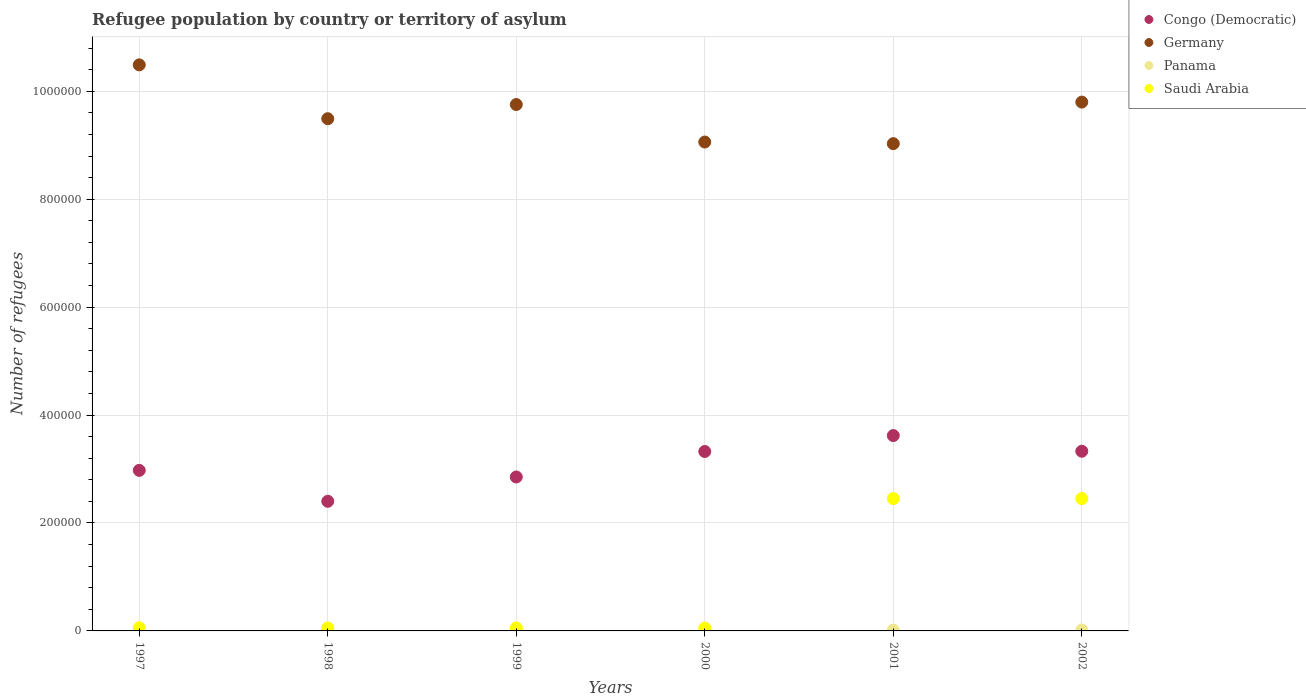What is the number of refugees in Saudi Arabia in 2002?
Make the answer very short. 2.45e+05. Across all years, what is the maximum number of refugees in Panama?
Give a very brief answer. 1573. Across all years, what is the minimum number of refugees in Saudi Arabia?
Offer a terse response. 5309. What is the total number of refugees in Saudi Arabia in the graph?
Your response must be concise. 5.13e+05. What is the difference between the number of refugees in Congo (Democratic) in 1997 and that in 1999?
Provide a short and direct response. 1.23e+04. What is the difference between the number of refugees in Congo (Democratic) in 2002 and the number of refugees in Germany in 1997?
Give a very brief answer. -7.16e+05. What is the average number of refugees in Congo (Democratic) per year?
Your answer should be compact. 3.08e+05. In the year 2000, what is the difference between the number of refugees in Saudi Arabia and number of refugees in Congo (Democratic)?
Ensure brevity in your answer.  -3.27e+05. What is the ratio of the number of refugees in Germany in 1999 to that in 2002?
Give a very brief answer. 1. What is the difference between the highest and the second highest number of refugees in Congo (Democratic)?
Make the answer very short. 2.90e+04. What is the difference between the highest and the lowest number of refugees in Germany?
Give a very brief answer. 1.46e+05. In how many years, is the number of refugees in Germany greater than the average number of refugees in Germany taken over all years?
Make the answer very short. 3. Is the sum of the number of refugees in Panama in 2000 and 2002 greater than the maximum number of refugees in Germany across all years?
Ensure brevity in your answer.  No. Does the number of refugees in Panama monotonically increase over the years?
Provide a succinct answer. No. Is the number of refugees in Saudi Arabia strictly less than the number of refugees in Panama over the years?
Give a very brief answer. No. How many dotlines are there?
Provide a short and direct response. 4. What is the difference between two consecutive major ticks on the Y-axis?
Make the answer very short. 2.00e+05. Are the values on the major ticks of Y-axis written in scientific E-notation?
Offer a terse response. No. Does the graph contain grids?
Ensure brevity in your answer.  Yes. How many legend labels are there?
Your answer should be very brief. 4. How are the legend labels stacked?
Your response must be concise. Vertical. What is the title of the graph?
Provide a succinct answer. Refugee population by country or territory of asylum. What is the label or title of the Y-axis?
Keep it short and to the point. Number of refugees. What is the Number of refugees in Congo (Democratic) in 1997?
Offer a very short reply. 2.98e+05. What is the Number of refugees in Germany in 1997?
Make the answer very short. 1.05e+06. What is the Number of refugees of Panama in 1997?
Your answer should be compact. 622. What is the Number of refugees in Saudi Arabia in 1997?
Make the answer very short. 5833. What is the Number of refugees in Congo (Democratic) in 1998?
Make the answer very short. 2.40e+05. What is the Number of refugees in Germany in 1998?
Provide a short and direct response. 9.49e+05. What is the Number of refugees of Panama in 1998?
Make the answer very short. 1188. What is the Number of refugees in Saudi Arabia in 1998?
Offer a terse response. 5531. What is the Number of refugees of Congo (Democratic) in 1999?
Give a very brief answer. 2.85e+05. What is the Number of refugees of Germany in 1999?
Offer a very short reply. 9.76e+05. What is the Number of refugees of Panama in 1999?
Give a very brief answer. 1321. What is the Number of refugees of Saudi Arabia in 1999?
Provide a short and direct response. 5562. What is the Number of refugees of Congo (Democratic) in 2000?
Keep it short and to the point. 3.33e+05. What is the Number of refugees of Germany in 2000?
Offer a terse response. 9.06e+05. What is the Number of refugees in Panama in 2000?
Give a very brief answer. 1313. What is the Number of refugees in Saudi Arabia in 2000?
Offer a very short reply. 5309. What is the Number of refugees in Congo (Democratic) in 2001?
Provide a succinct answer. 3.62e+05. What is the Number of refugees of Germany in 2001?
Your answer should be compact. 9.03e+05. What is the Number of refugees of Panama in 2001?
Your response must be concise. 1470. What is the Number of refugees of Saudi Arabia in 2001?
Ensure brevity in your answer.  2.45e+05. What is the Number of refugees of Congo (Democratic) in 2002?
Offer a very short reply. 3.33e+05. What is the Number of refugees in Germany in 2002?
Your answer should be compact. 9.80e+05. What is the Number of refugees in Panama in 2002?
Give a very brief answer. 1573. What is the Number of refugees of Saudi Arabia in 2002?
Offer a terse response. 2.45e+05. Across all years, what is the maximum Number of refugees of Congo (Democratic)?
Give a very brief answer. 3.62e+05. Across all years, what is the maximum Number of refugees of Germany?
Keep it short and to the point. 1.05e+06. Across all years, what is the maximum Number of refugees in Panama?
Offer a terse response. 1573. Across all years, what is the maximum Number of refugees of Saudi Arabia?
Offer a terse response. 2.45e+05. Across all years, what is the minimum Number of refugees in Congo (Democratic)?
Your response must be concise. 2.40e+05. Across all years, what is the minimum Number of refugees in Germany?
Provide a succinct answer. 9.03e+05. Across all years, what is the minimum Number of refugees in Panama?
Give a very brief answer. 622. Across all years, what is the minimum Number of refugees in Saudi Arabia?
Your answer should be compact. 5309. What is the total Number of refugees of Congo (Democratic) in the graph?
Offer a very short reply. 1.85e+06. What is the total Number of refugees of Germany in the graph?
Your answer should be very brief. 5.76e+06. What is the total Number of refugees of Panama in the graph?
Give a very brief answer. 7487. What is the total Number of refugees in Saudi Arabia in the graph?
Offer a terse response. 5.13e+05. What is the difference between the Number of refugees of Congo (Democratic) in 1997 and that in 1998?
Keep it short and to the point. 5.73e+04. What is the difference between the Number of refugees of Germany in 1997 and that in 1998?
Make the answer very short. 9.98e+04. What is the difference between the Number of refugees of Panama in 1997 and that in 1998?
Provide a succinct answer. -566. What is the difference between the Number of refugees of Saudi Arabia in 1997 and that in 1998?
Give a very brief answer. 302. What is the difference between the Number of refugees of Congo (Democratic) in 1997 and that in 1999?
Provide a succinct answer. 1.23e+04. What is the difference between the Number of refugees of Germany in 1997 and that in 1999?
Ensure brevity in your answer.  7.35e+04. What is the difference between the Number of refugees of Panama in 1997 and that in 1999?
Make the answer very short. -699. What is the difference between the Number of refugees of Saudi Arabia in 1997 and that in 1999?
Your answer should be very brief. 271. What is the difference between the Number of refugees in Congo (Democratic) in 1997 and that in 2000?
Keep it short and to the point. -3.50e+04. What is the difference between the Number of refugees of Germany in 1997 and that in 2000?
Keep it short and to the point. 1.43e+05. What is the difference between the Number of refugees of Panama in 1997 and that in 2000?
Your answer should be compact. -691. What is the difference between the Number of refugees of Saudi Arabia in 1997 and that in 2000?
Your answer should be very brief. 524. What is the difference between the Number of refugees of Congo (Democratic) in 1997 and that in 2001?
Your response must be concise. -6.45e+04. What is the difference between the Number of refugees of Germany in 1997 and that in 2001?
Offer a very short reply. 1.46e+05. What is the difference between the Number of refugees of Panama in 1997 and that in 2001?
Keep it short and to the point. -848. What is the difference between the Number of refugees in Saudi Arabia in 1997 and that in 2001?
Provide a short and direct response. -2.39e+05. What is the difference between the Number of refugees in Congo (Democratic) in 1997 and that in 2002?
Ensure brevity in your answer.  -3.54e+04. What is the difference between the Number of refugees of Germany in 1997 and that in 2002?
Provide a succinct answer. 6.90e+04. What is the difference between the Number of refugees in Panama in 1997 and that in 2002?
Provide a succinct answer. -951. What is the difference between the Number of refugees in Saudi Arabia in 1997 and that in 2002?
Offer a terse response. -2.39e+05. What is the difference between the Number of refugees of Congo (Democratic) in 1998 and that in 1999?
Ensure brevity in your answer.  -4.51e+04. What is the difference between the Number of refugees in Germany in 1998 and that in 1999?
Provide a short and direct response. -2.63e+04. What is the difference between the Number of refugees in Panama in 1998 and that in 1999?
Your answer should be compact. -133. What is the difference between the Number of refugees of Saudi Arabia in 1998 and that in 1999?
Your response must be concise. -31. What is the difference between the Number of refugees in Congo (Democratic) in 1998 and that in 2000?
Provide a succinct answer. -9.23e+04. What is the difference between the Number of refugees in Germany in 1998 and that in 2000?
Offer a very short reply. 4.32e+04. What is the difference between the Number of refugees in Panama in 1998 and that in 2000?
Offer a very short reply. -125. What is the difference between the Number of refugees in Saudi Arabia in 1998 and that in 2000?
Ensure brevity in your answer.  222. What is the difference between the Number of refugees of Congo (Democratic) in 1998 and that in 2001?
Make the answer very short. -1.22e+05. What is the difference between the Number of refugees in Germany in 1998 and that in 2001?
Ensure brevity in your answer.  4.62e+04. What is the difference between the Number of refugees of Panama in 1998 and that in 2001?
Give a very brief answer. -282. What is the difference between the Number of refugees of Saudi Arabia in 1998 and that in 2001?
Offer a terse response. -2.40e+05. What is the difference between the Number of refugees in Congo (Democratic) in 1998 and that in 2002?
Your answer should be very brief. -9.28e+04. What is the difference between the Number of refugees in Germany in 1998 and that in 2002?
Give a very brief answer. -3.08e+04. What is the difference between the Number of refugees of Panama in 1998 and that in 2002?
Give a very brief answer. -385. What is the difference between the Number of refugees of Saudi Arabia in 1998 and that in 2002?
Your answer should be compact. -2.40e+05. What is the difference between the Number of refugees in Congo (Democratic) in 1999 and that in 2000?
Keep it short and to the point. -4.72e+04. What is the difference between the Number of refugees of Germany in 1999 and that in 2000?
Offer a terse response. 6.95e+04. What is the difference between the Number of refugees in Saudi Arabia in 1999 and that in 2000?
Make the answer very short. 253. What is the difference between the Number of refugees of Congo (Democratic) in 1999 and that in 2001?
Provide a short and direct response. -7.67e+04. What is the difference between the Number of refugees in Germany in 1999 and that in 2001?
Offer a very short reply. 7.25e+04. What is the difference between the Number of refugees in Panama in 1999 and that in 2001?
Your response must be concise. -149. What is the difference between the Number of refugees of Saudi Arabia in 1999 and that in 2001?
Make the answer very short. -2.40e+05. What is the difference between the Number of refugees of Congo (Democratic) in 1999 and that in 2002?
Your answer should be very brief. -4.77e+04. What is the difference between the Number of refugees in Germany in 1999 and that in 2002?
Your answer should be compact. -4500. What is the difference between the Number of refugees of Panama in 1999 and that in 2002?
Provide a succinct answer. -252. What is the difference between the Number of refugees in Saudi Arabia in 1999 and that in 2002?
Provide a short and direct response. -2.40e+05. What is the difference between the Number of refugees in Congo (Democratic) in 2000 and that in 2001?
Give a very brief answer. -2.95e+04. What is the difference between the Number of refugees of Germany in 2000 and that in 2001?
Offer a terse response. 3000. What is the difference between the Number of refugees of Panama in 2000 and that in 2001?
Offer a terse response. -157. What is the difference between the Number of refugees of Saudi Arabia in 2000 and that in 2001?
Provide a succinct answer. -2.40e+05. What is the difference between the Number of refugees in Congo (Democratic) in 2000 and that in 2002?
Provide a succinct answer. -469. What is the difference between the Number of refugees of Germany in 2000 and that in 2002?
Make the answer very short. -7.40e+04. What is the difference between the Number of refugees in Panama in 2000 and that in 2002?
Offer a terse response. -260. What is the difference between the Number of refugees of Saudi Arabia in 2000 and that in 2002?
Offer a terse response. -2.40e+05. What is the difference between the Number of refugees of Congo (Democratic) in 2001 and that in 2002?
Your answer should be compact. 2.90e+04. What is the difference between the Number of refugees of Germany in 2001 and that in 2002?
Your answer should be compact. -7.70e+04. What is the difference between the Number of refugees of Panama in 2001 and that in 2002?
Provide a short and direct response. -103. What is the difference between the Number of refugees in Congo (Democratic) in 1997 and the Number of refugees in Germany in 1998?
Your answer should be compact. -6.52e+05. What is the difference between the Number of refugees in Congo (Democratic) in 1997 and the Number of refugees in Panama in 1998?
Make the answer very short. 2.96e+05. What is the difference between the Number of refugees of Congo (Democratic) in 1997 and the Number of refugees of Saudi Arabia in 1998?
Provide a succinct answer. 2.92e+05. What is the difference between the Number of refugees in Germany in 1997 and the Number of refugees in Panama in 1998?
Your response must be concise. 1.05e+06. What is the difference between the Number of refugees in Germany in 1997 and the Number of refugees in Saudi Arabia in 1998?
Your response must be concise. 1.04e+06. What is the difference between the Number of refugees in Panama in 1997 and the Number of refugees in Saudi Arabia in 1998?
Ensure brevity in your answer.  -4909. What is the difference between the Number of refugees of Congo (Democratic) in 1997 and the Number of refugees of Germany in 1999?
Offer a terse response. -6.78e+05. What is the difference between the Number of refugees of Congo (Democratic) in 1997 and the Number of refugees of Panama in 1999?
Your response must be concise. 2.96e+05. What is the difference between the Number of refugees in Congo (Democratic) in 1997 and the Number of refugees in Saudi Arabia in 1999?
Keep it short and to the point. 2.92e+05. What is the difference between the Number of refugees in Germany in 1997 and the Number of refugees in Panama in 1999?
Keep it short and to the point. 1.05e+06. What is the difference between the Number of refugees in Germany in 1997 and the Number of refugees in Saudi Arabia in 1999?
Your answer should be very brief. 1.04e+06. What is the difference between the Number of refugees in Panama in 1997 and the Number of refugees in Saudi Arabia in 1999?
Provide a short and direct response. -4940. What is the difference between the Number of refugees of Congo (Democratic) in 1997 and the Number of refugees of Germany in 2000?
Make the answer very short. -6.08e+05. What is the difference between the Number of refugees of Congo (Democratic) in 1997 and the Number of refugees of Panama in 2000?
Provide a short and direct response. 2.96e+05. What is the difference between the Number of refugees in Congo (Democratic) in 1997 and the Number of refugees in Saudi Arabia in 2000?
Give a very brief answer. 2.92e+05. What is the difference between the Number of refugees of Germany in 1997 and the Number of refugees of Panama in 2000?
Give a very brief answer. 1.05e+06. What is the difference between the Number of refugees in Germany in 1997 and the Number of refugees in Saudi Arabia in 2000?
Your answer should be very brief. 1.04e+06. What is the difference between the Number of refugees in Panama in 1997 and the Number of refugees in Saudi Arabia in 2000?
Ensure brevity in your answer.  -4687. What is the difference between the Number of refugees of Congo (Democratic) in 1997 and the Number of refugees of Germany in 2001?
Your response must be concise. -6.05e+05. What is the difference between the Number of refugees of Congo (Democratic) in 1997 and the Number of refugees of Panama in 2001?
Your response must be concise. 2.96e+05. What is the difference between the Number of refugees of Congo (Democratic) in 1997 and the Number of refugees of Saudi Arabia in 2001?
Your answer should be compact. 5.23e+04. What is the difference between the Number of refugees in Germany in 1997 and the Number of refugees in Panama in 2001?
Keep it short and to the point. 1.05e+06. What is the difference between the Number of refugees in Germany in 1997 and the Number of refugees in Saudi Arabia in 2001?
Ensure brevity in your answer.  8.04e+05. What is the difference between the Number of refugees in Panama in 1997 and the Number of refugees in Saudi Arabia in 2001?
Give a very brief answer. -2.45e+05. What is the difference between the Number of refugees of Congo (Democratic) in 1997 and the Number of refugees of Germany in 2002?
Ensure brevity in your answer.  -6.82e+05. What is the difference between the Number of refugees in Congo (Democratic) in 1997 and the Number of refugees in Panama in 2002?
Offer a terse response. 2.96e+05. What is the difference between the Number of refugees of Congo (Democratic) in 1997 and the Number of refugees of Saudi Arabia in 2002?
Your response must be concise. 5.22e+04. What is the difference between the Number of refugees of Germany in 1997 and the Number of refugees of Panama in 2002?
Keep it short and to the point. 1.05e+06. What is the difference between the Number of refugees of Germany in 1997 and the Number of refugees of Saudi Arabia in 2002?
Provide a succinct answer. 8.04e+05. What is the difference between the Number of refugees of Panama in 1997 and the Number of refugees of Saudi Arabia in 2002?
Offer a very short reply. -2.45e+05. What is the difference between the Number of refugees of Congo (Democratic) in 1998 and the Number of refugees of Germany in 1999?
Offer a very short reply. -7.35e+05. What is the difference between the Number of refugees of Congo (Democratic) in 1998 and the Number of refugees of Panama in 1999?
Keep it short and to the point. 2.39e+05. What is the difference between the Number of refugees in Congo (Democratic) in 1998 and the Number of refugees in Saudi Arabia in 1999?
Keep it short and to the point. 2.35e+05. What is the difference between the Number of refugees in Germany in 1998 and the Number of refugees in Panama in 1999?
Give a very brief answer. 9.48e+05. What is the difference between the Number of refugees of Germany in 1998 and the Number of refugees of Saudi Arabia in 1999?
Give a very brief answer. 9.44e+05. What is the difference between the Number of refugees in Panama in 1998 and the Number of refugees in Saudi Arabia in 1999?
Offer a terse response. -4374. What is the difference between the Number of refugees of Congo (Democratic) in 1998 and the Number of refugees of Germany in 2000?
Give a very brief answer. -6.66e+05. What is the difference between the Number of refugees in Congo (Democratic) in 1998 and the Number of refugees in Panama in 2000?
Your answer should be very brief. 2.39e+05. What is the difference between the Number of refugees of Congo (Democratic) in 1998 and the Number of refugees of Saudi Arabia in 2000?
Make the answer very short. 2.35e+05. What is the difference between the Number of refugees of Germany in 1998 and the Number of refugees of Panama in 2000?
Ensure brevity in your answer.  9.48e+05. What is the difference between the Number of refugees of Germany in 1998 and the Number of refugees of Saudi Arabia in 2000?
Provide a short and direct response. 9.44e+05. What is the difference between the Number of refugees of Panama in 1998 and the Number of refugees of Saudi Arabia in 2000?
Give a very brief answer. -4121. What is the difference between the Number of refugees in Congo (Democratic) in 1998 and the Number of refugees in Germany in 2001?
Your response must be concise. -6.63e+05. What is the difference between the Number of refugees of Congo (Democratic) in 1998 and the Number of refugees of Panama in 2001?
Ensure brevity in your answer.  2.39e+05. What is the difference between the Number of refugees in Congo (Democratic) in 1998 and the Number of refugees in Saudi Arabia in 2001?
Provide a short and direct response. -5054. What is the difference between the Number of refugees of Germany in 1998 and the Number of refugees of Panama in 2001?
Provide a succinct answer. 9.48e+05. What is the difference between the Number of refugees of Germany in 1998 and the Number of refugees of Saudi Arabia in 2001?
Give a very brief answer. 7.04e+05. What is the difference between the Number of refugees of Panama in 1998 and the Number of refugees of Saudi Arabia in 2001?
Provide a succinct answer. -2.44e+05. What is the difference between the Number of refugees in Congo (Democratic) in 1998 and the Number of refugees in Germany in 2002?
Offer a terse response. -7.40e+05. What is the difference between the Number of refugees of Congo (Democratic) in 1998 and the Number of refugees of Panama in 2002?
Give a very brief answer. 2.39e+05. What is the difference between the Number of refugees in Congo (Democratic) in 1998 and the Number of refugees in Saudi Arabia in 2002?
Your answer should be very brief. -5076. What is the difference between the Number of refugees of Germany in 1998 and the Number of refugees of Panama in 2002?
Offer a very short reply. 9.48e+05. What is the difference between the Number of refugees of Germany in 1998 and the Number of refugees of Saudi Arabia in 2002?
Provide a succinct answer. 7.04e+05. What is the difference between the Number of refugees of Panama in 1998 and the Number of refugees of Saudi Arabia in 2002?
Your answer should be compact. -2.44e+05. What is the difference between the Number of refugees of Congo (Democratic) in 1999 and the Number of refugees of Germany in 2000?
Your answer should be compact. -6.21e+05. What is the difference between the Number of refugees of Congo (Democratic) in 1999 and the Number of refugees of Panama in 2000?
Offer a terse response. 2.84e+05. What is the difference between the Number of refugees of Congo (Democratic) in 1999 and the Number of refugees of Saudi Arabia in 2000?
Give a very brief answer. 2.80e+05. What is the difference between the Number of refugees of Germany in 1999 and the Number of refugees of Panama in 2000?
Your answer should be very brief. 9.74e+05. What is the difference between the Number of refugees of Germany in 1999 and the Number of refugees of Saudi Arabia in 2000?
Give a very brief answer. 9.70e+05. What is the difference between the Number of refugees of Panama in 1999 and the Number of refugees of Saudi Arabia in 2000?
Your answer should be compact. -3988. What is the difference between the Number of refugees in Congo (Democratic) in 1999 and the Number of refugees in Germany in 2001?
Offer a terse response. -6.18e+05. What is the difference between the Number of refugees of Congo (Democratic) in 1999 and the Number of refugees of Panama in 2001?
Provide a succinct answer. 2.84e+05. What is the difference between the Number of refugees in Congo (Democratic) in 1999 and the Number of refugees in Saudi Arabia in 2001?
Make the answer very short. 4.00e+04. What is the difference between the Number of refugees of Germany in 1999 and the Number of refugees of Panama in 2001?
Provide a short and direct response. 9.74e+05. What is the difference between the Number of refugees in Germany in 1999 and the Number of refugees in Saudi Arabia in 2001?
Your response must be concise. 7.30e+05. What is the difference between the Number of refugees in Panama in 1999 and the Number of refugees in Saudi Arabia in 2001?
Keep it short and to the point. -2.44e+05. What is the difference between the Number of refugees of Congo (Democratic) in 1999 and the Number of refugees of Germany in 2002?
Ensure brevity in your answer.  -6.95e+05. What is the difference between the Number of refugees in Congo (Democratic) in 1999 and the Number of refugees in Panama in 2002?
Make the answer very short. 2.84e+05. What is the difference between the Number of refugees in Congo (Democratic) in 1999 and the Number of refugees in Saudi Arabia in 2002?
Your response must be concise. 4.00e+04. What is the difference between the Number of refugees of Germany in 1999 and the Number of refugees of Panama in 2002?
Make the answer very short. 9.74e+05. What is the difference between the Number of refugees in Germany in 1999 and the Number of refugees in Saudi Arabia in 2002?
Give a very brief answer. 7.30e+05. What is the difference between the Number of refugees in Panama in 1999 and the Number of refugees in Saudi Arabia in 2002?
Your answer should be very brief. -2.44e+05. What is the difference between the Number of refugees in Congo (Democratic) in 2000 and the Number of refugees in Germany in 2001?
Your response must be concise. -5.70e+05. What is the difference between the Number of refugees of Congo (Democratic) in 2000 and the Number of refugees of Panama in 2001?
Keep it short and to the point. 3.31e+05. What is the difference between the Number of refugees of Congo (Democratic) in 2000 and the Number of refugees of Saudi Arabia in 2001?
Your answer should be compact. 8.72e+04. What is the difference between the Number of refugees in Germany in 2000 and the Number of refugees in Panama in 2001?
Provide a succinct answer. 9.05e+05. What is the difference between the Number of refugees in Germany in 2000 and the Number of refugees in Saudi Arabia in 2001?
Provide a succinct answer. 6.61e+05. What is the difference between the Number of refugees of Panama in 2000 and the Number of refugees of Saudi Arabia in 2001?
Keep it short and to the point. -2.44e+05. What is the difference between the Number of refugees in Congo (Democratic) in 2000 and the Number of refugees in Germany in 2002?
Offer a very short reply. -6.47e+05. What is the difference between the Number of refugees in Congo (Democratic) in 2000 and the Number of refugees in Panama in 2002?
Provide a short and direct response. 3.31e+05. What is the difference between the Number of refugees in Congo (Democratic) in 2000 and the Number of refugees in Saudi Arabia in 2002?
Offer a terse response. 8.72e+04. What is the difference between the Number of refugees of Germany in 2000 and the Number of refugees of Panama in 2002?
Keep it short and to the point. 9.04e+05. What is the difference between the Number of refugees of Germany in 2000 and the Number of refugees of Saudi Arabia in 2002?
Keep it short and to the point. 6.61e+05. What is the difference between the Number of refugees of Panama in 2000 and the Number of refugees of Saudi Arabia in 2002?
Give a very brief answer. -2.44e+05. What is the difference between the Number of refugees of Congo (Democratic) in 2001 and the Number of refugees of Germany in 2002?
Provide a succinct answer. -6.18e+05. What is the difference between the Number of refugees in Congo (Democratic) in 2001 and the Number of refugees in Panama in 2002?
Your response must be concise. 3.60e+05. What is the difference between the Number of refugees in Congo (Democratic) in 2001 and the Number of refugees in Saudi Arabia in 2002?
Provide a succinct answer. 1.17e+05. What is the difference between the Number of refugees in Germany in 2001 and the Number of refugees in Panama in 2002?
Keep it short and to the point. 9.01e+05. What is the difference between the Number of refugees of Germany in 2001 and the Number of refugees of Saudi Arabia in 2002?
Make the answer very short. 6.58e+05. What is the difference between the Number of refugees of Panama in 2001 and the Number of refugees of Saudi Arabia in 2002?
Provide a succinct answer. -2.44e+05. What is the average Number of refugees in Congo (Democratic) per year?
Make the answer very short. 3.08e+05. What is the average Number of refugees in Germany per year?
Your answer should be compact. 9.60e+05. What is the average Number of refugees of Panama per year?
Provide a succinct answer. 1247.83. What is the average Number of refugees of Saudi Arabia per year?
Make the answer very short. 8.55e+04. In the year 1997, what is the difference between the Number of refugees of Congo (Democratic) and Number of refugees of Germany?
Offer a very short reply. -7.51e+05. In the year 1997, what is the difference between the Number of refugees of Congo (Democratic) and Number of refugees of Panama?
Ensure brevity in your answer.  2.97e+05. In the year 1997, what is the difference between the Number of refugees in Congo (Democratic) and Number of refugees in Saudi Arabia?
Keep it short and to the point. 2.92e+05. In the year 1997, what is the difference between the Number of refugees of Germany and Number of refugees of Panama?
Your answer should be compact. 1.05e+06. In the year 1997, what is the difference between the Number of refugees of Germany and Number of refugees of Saudi Arabia?
Offer a terse response. 1.04e+06. In the year 1997, what is the difference between the Number of refugees of Panama and Number of refugees of Saudi Arabia?
Keep it short and to the point. -5211. In the year 1998, what is the difference between the Number of refugees in Congo (Democratic) and Number of refugees in Germany?
Offer a very short reply. -7.09e+05. In the year 1998, what is the difference between the Number of refugees in Congo (Democratic) and Number of refugees in Panama?
Provide a short and direct response. 2.39e+05. In the year 1998, what is the difference between the Number of refugees of Congo (Democratic) and Number of refugees of Saudi Arabia?
Your answer should be compact. 2.35e+05. In the year 1998, what is the difference between the Number of refugees of Germany and Number of refugees of Panama?
Provide a short and direct response. 9.48e+05. In the year 1998, what is the difference between the Number of refugees of Germany and Number of refugees of Saudi Arabia?
Your answer should be compact. 9.44e+05. In the year 1998, what is the difference between the Number of refugees of Panama and Number of refugees of Saudi Arabia?
Give a very brief answer. -4343. In the year 1999, what is the difference between the Number of refugees of Congo (Democratic) and Number of refugees of Germany?
Your response must be concise. -6.90e+05. In the year 1999, what is the difference between the Number of refugees in Congo (Democratic) and Number of refugees in Panama?
Ensure brevity in your answer.  2.84e+05. In the year 1999, what is the difference between the Number of refugees of Congo (Democratic) and Number of refugees of Saudi Arabia?
Provide a succinct answer. 2.80e+05. In the year 1999, what is the difference between the Number of refugees in Germany and Number of refugees in Panama?
Give a very brief answer. 9.74e+05. In the year 1999, what is the difference between the Number of refugees in Germany and Number of refugees in Saudi Arabia?
Provide a short and direct response. 9.70e+05. In the year 1999, what is the difference between the Number of refugees in Panama and Number of refugees in Saudi Arabia?
Your answer should be very brief. -4241. In the year 2000, what is the difference between the Number of refugees in Congo (Democratic) and Number of refugees in Germany?
Ensure brevity in your answer.  -5.73e+05. In the year 2000, what is the difference between the Number of refugees of Congo (Democratic) and Number of refugees of Panama?
Give a very brief answer. 3.31e+05. In the year 2000, what is the difference between the Number of refugees of Congo (Democratic) and Number of refugees of Saudi Arabia?
Give a very brief answer. 3.27e+05. In the year 2000, what is the difference between the Number of refugees in Germany and Number of refugees in Panama?
Offer a terse response. 9.05e+05. In the year 2000, what is the difference between the Number of refugees in Germany and Number of refugees in Saudi Arabia?
Provide a succinct answer. 9.01e+05. In the year 2000, what is the difference between the Number of refugees of Panama and Number of refugees of Saudi Arabia?
Keep it short and to the point. -3996. In the year 2001, what is the difference between the Number of refugees of Congo (Democratic) and Number of refugees of Germany?
Make the answer very short. -5.41e+05. In the year 2001, what is the difference between the Number of refugees in Congo (Democratic) and Number of refugees in Panama?
Your answer should be compact. 3.61e+05. In the year 2001, what is the difference between the Number of refugees of Congo (Democratic) and Number of refugees of Saudi Arabia?
Provide a short and direct response. 1.17e+05. In the year 2001, what is the difference between the Number of refugees in Germany and Number of refugees in Panama?
Your response must be concise. 9.02e+05. In the year 2001, what is the difference between the Number of refugees of Germany and Number of refugees of Saudi Arabia?
Your response must be concise. 6.58e+05. In the year 2001, what is the difference between the Number of refugees of Panama and Number of refugees of Saudi Arabia?
Your response must be concise. -2.44e+05. In the year 2002, what is the difference between the Number of refugees of Congo (Democratic) and Number of refugees of Germany?
Ensure brevity in your answer.  -6.47e+05. In the year 2002, what is the difference between the Number of refugees of Congo (Democratic) and Number of refugees of Panama?
Your response must be concise. 3.31e+05. In the year 2002, what is the difference between the Number of refugees of Congo (Democratic) and Number of refugees of Saudi Arabia?
Make the answer very short. 8.77e+04. In the year 2002, what is the difference between the Number of refugees in Germany and Number of refugees in Panama?
Provide a succinct answer. 9.78e+05. In the year 2002, what is the difference between the Number of refugees of Germany and Number of refugees of Saudi Arabia?
Your answer should be compact. 7.35e+05. In the year 2002, what is the difference between the Number of refugees of Panama and Number of refugees of Saudi Arabia?
Provide a short and direct response. -2.44e+05. What is the ratio of the Number of refugees in Congo (Democratic) in 1997 to that in 1998?
Offer a terse response. 1.24. What is the ratio of the Number of refugees of Germany in 1997 to that in 1998?
Your answer should be very brief. 1.11. What is the ratio of the Number of refugees of Panama in 1997 to that in 1998?
Provide a succinct answer. 0.52. What is the ratio of the Number of refugees in Saudi Arabia in 1997 to that in 1998?
Offer a very short reply. 1.05. What is the ratio of the Number of refugees in Congo (Democratic) in 1997 to that in 1999?
Provide a succinct answer. 1.04. What is the ratio of the Number of refugees of Germany in 1997 to that in 1999?
Keep it short and to the point. 1.08. What is the ratio of the Number of refugees of Panama in 1997 to that in 1999?
Your answer should be compact. 0.47. What is the ratio of the Number of refugees in Saudi Arabia in 1997 to that in 1999?
Your response must be concise. 1.05. What is the ratio of the Number of refugees of Congo (Democratic) in 1997 to that in 2000?
Your response must be concise. 0.89. What is the ratio of the Number of refugees in Germany in 1997 to that in 2000?
Your answer should be very brief. 1.16. What is the ratio of the Number of refugees in Panama in 1997 to that in 2000?
Provide a short and direct response. 0.47. What is the ratio of the Number of refugees in Saudi Arabia in 1997 to that in 2000?
Offer a terse response. 1.1. What is the ratio of the Number of refugees of Congo (Democratic) in 1997 to that in 2001?
Offer a very short reply. 0.82. What is the ratio of the Number of refugees of Germany in 1997 to that in 2001?
Your response must be concise. 1.16. What is the ratio of the Number of refugees of Panama in 1997 to that in 2001?
Give a very brief answer. 0.42. What is the ratio of the Number of refugees of Saudi Arabia in 1997 to that in 2001?
Offer a terse response. 0.02. What is the ratio of the Number of refugees of Congo (Democratic) in 1997 to that in 2002?
Your answer should be compact. 0.89. What is the ratio of the Number of refugees of Germany in 1997 to that in 2002?
Give a very brief answer. 1.07. What is the ratio of the Number of refugees in Panama in 1997 to that in 2002?
Provide a succinct answer. 0.4. What is the ratio of the Number of refugees of Saudi Arabia in 1997 to that in 2002?
Give a very brief answer. 0.02. What is the ratio of the Number of refugees in Congo (Democratic) in 1998 to that in 1999?
Provide a succinct answer. 0.84. What is the ratio of the Number of refugees in Panama in 1998 to that in 1999?
Make the answer very short. 0.9. What is the ratio of the Number of refugees of Congo (Democratic) in 1998 to that in 2000?
Keep it short and to the point. 0.72. What is the ratio of the Number of refugees in Germany in 1998 to that in 2000?
Keep it short and to the point. 1.05. What is the ratio of the Number of refugees of Panama in 1998 to that in 2000?
Provide a short and direct response. 0.9. What is the ratio of the Number of refugees in Saudi Arabia in 1998 to that in 2000?
Offer a very short reply. 1.04. What is the ratio of the Number of refugees of Congo (Democratic) in 1998 to that in 2001?
Your response must be concise. 0.66. What is the ratio of the Number of refugees in Germany in 1998 to that in 2001?
Give a very brief answer. 1.05. What is the ratio of the Number of refugees in Panama in 1998 to that in 2001?
Offer a terse response. 0.81. What is the ratio of the Number of refugees in Saudi Arabia in 1998 to that in 2001?
Your answer should be very brief. 0.02. What is the ratio of the Number of refugees in Congo (Democratic) in 1998 to that in 2002?
Offer a terse response. 0.72. What is the ratio of the Number of refugees in Germany in 1998 to that in 2002?
Offer a very short reply. 0.97. What is the ratio of the Number of refugees of Panama in 1998 to that in 2002?
Give a very brief answer. 0.76. What is the ratio of the Number of refugees of Saudi Arabia in 1998 to that in 2002?
Your answer should be compact. 0.02. What is the ratio of the Number of refugees in Congo (Democratic) in 1999 to that in 2000?
Your answer should be very brief. 0.86. What is the ratio of the Number of refugees in Germany in 1999 to that in 2000?
Your answer should be very brief. 1.08. What is the ratio of the Number of refugees in Saudi Arabia in 1999 to that in 2000?
Your response must be concise. 1.05. What is the ratio of the Number of refugees of Congo (Democratic) in 1999 to that in 2001?
Give a very brief answer. 0.79. What is the ratio of the Number of refugees in Germany in 1999 to that in 2001?
Provide a succinct answer. 1.08. What is the ratio of the Number of refugees in Panama in 1999 to that in 2001?
Make the answer very short. 0.9. What is the ratio of the Number of refugees in Saudi Arabia in 1999 to that in 2001?
Offer a very short reply. 0.02. What is the ratio of the Number of refugees of Congo (Democratic) in 1999 to that in 2002?
Keep it short and to the point. 0.86. What is the ratio of the Number of refugees in Panama in 1999 to that in 2002?
Your response must be concise. 0.84. What is the ratio of the Number of refugees of Saudi Arabia in 1999 to that in 2002?
Your answer should be compact. 0.02. What is the ratio of the Number of refugees of Congo (Democratic) in 2000 to that in 2001?
Offer a very short reply. 0.92. What is the ratio of the Number of refugees of Panama in 2000 to that in 2001?
Give a very brief answer. 0.89. What is the ratio of the Number of refugees in Saudi Arabia in 2000 to that in 2001?
Provide a succinct answer. 0.02. What is the ratio of the Number of refugees of Germany in 2000 to that in 2002?
Ensure brevity in your answer.  0.92. What is the ratio of the Number of refugees in Panama in 2000 to that in 2002?
Make the answer very short. 0.83. What is the ratio of the Number of refugees in Saudi Arabia in 2000 to that in 2002?
Your answer should be compact. 0.02. What is the ratio of the Number of refugees of Congo (Democratic) in 2001 to that in 2002?
Make the answer very short. 1.09. What is the ratio of the Number of refugees in Germany in 2001 to that in 2002?
Provide a short and direct response. 0.92. What is the ratio of the Number of refugees of Panama in 2001 to that in 2002?
Provide a short and direct response. 0.93. What is the difference between the highest and the second highest Number of refugees in Congo (Democratic)?
Offer a very short reply. 2.90e+04. What is the difference between the highest and the second highest Number of refugees in Germany?
Your response must be concise. 6.90e+04. What is the difference between the highest and the second highest Number of refugees in Panama?
Make the answer very short. 103. What is the difference between the highest and the lowest Number of refugees of Congo (Democratic)?
Offer a very short reply. 1.22e+05. What is the difference between the highest and the lowest Number of refugees in Germany?
Provide a short and direct response. 1.46e+05. What is the difference between the highest and the lowest Number of refugees in Panama?
Offer a terse response. 951. What is the difference between the highest and the lowest Number of refugees in Saudi Arabia?
Keep it short and to the point. 2.40e+05. 